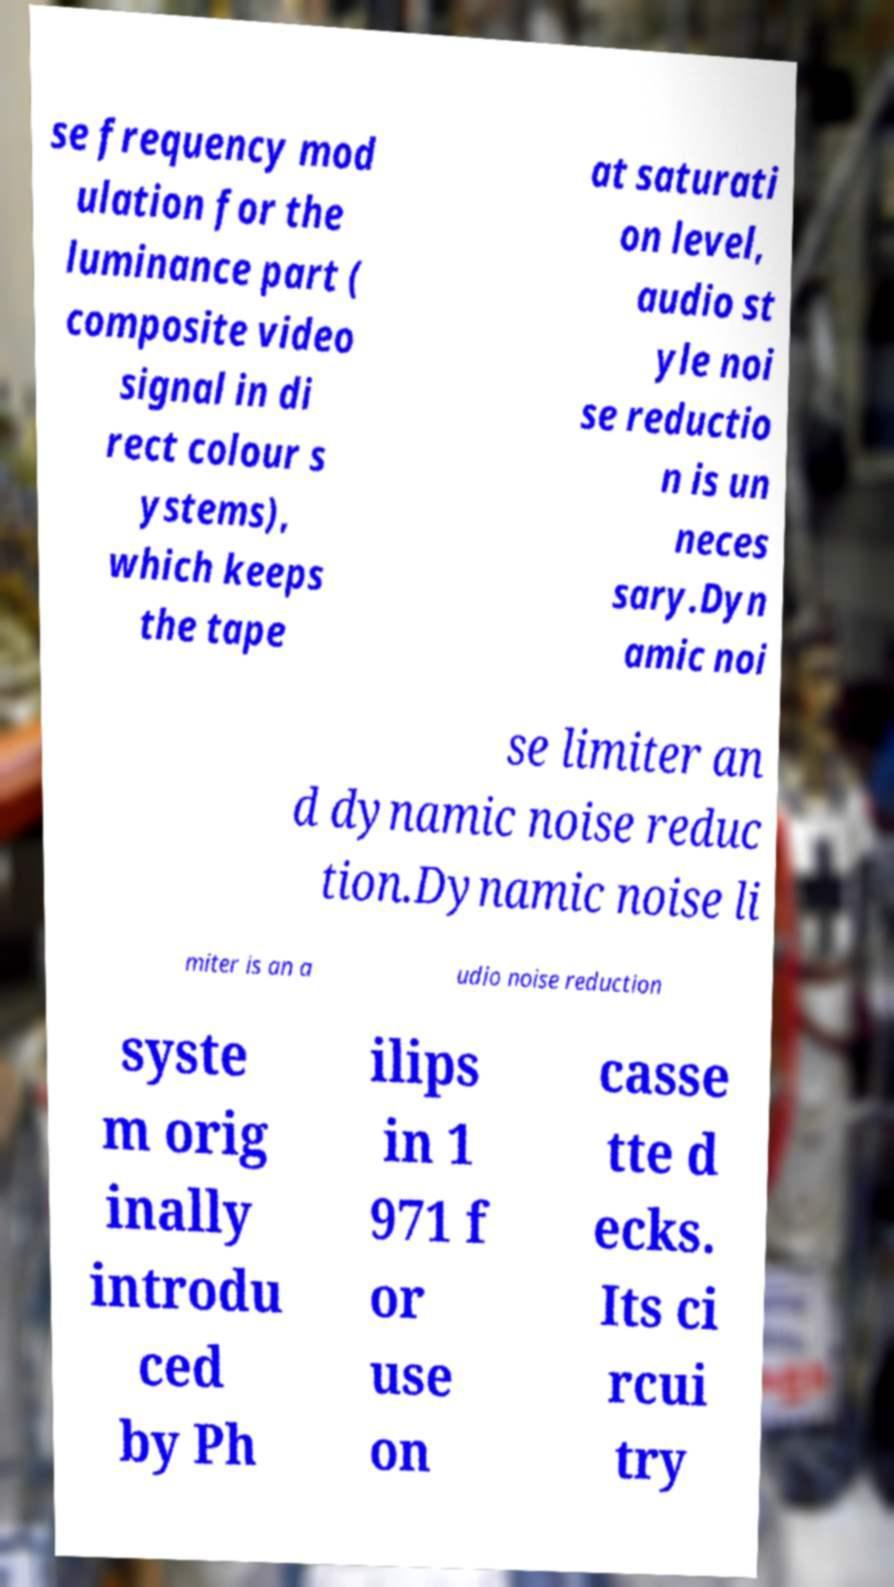Could you extract and type out the text from this image? se frequency mod ulation for the luminance part ( composite video signal in di rect colour s ystems), which keeps the tape at saturati on level, audio st yle noi se reductio n is un neces sary.Dyn amic noi se limiter an d dynamic noise reduc tion.Dynamic noise li miter is an a udio noise reduction syste m orig inally introdu ced by Ph ilips in 1 971 f or use on casse tte d ecks. Its ci rcui try 